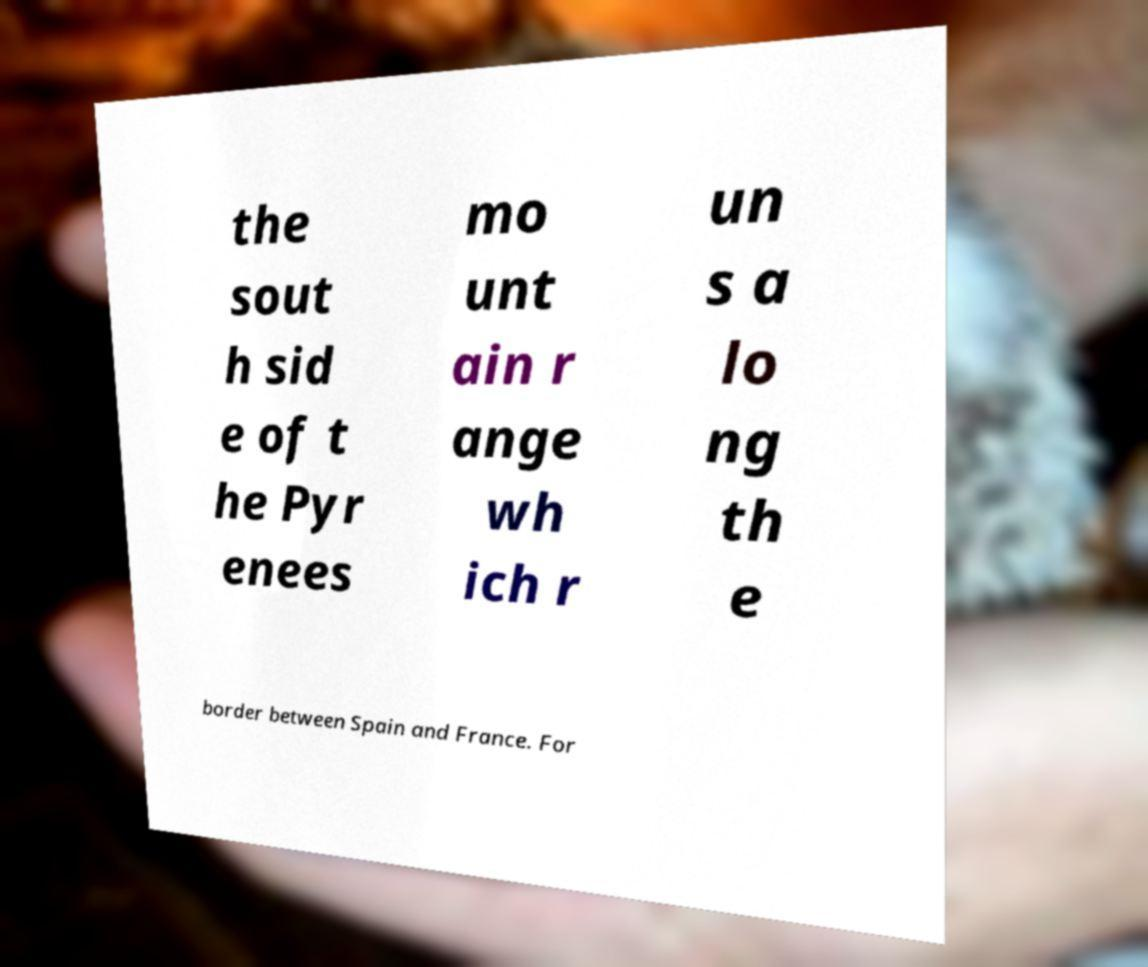For documentation purposes, I need the text within this image transcribed. Could you provide that? the sout h sid e of t he Pyr enees mo unt ain r ange wh ich r un s a lo ng th e border between Spain and France. For 